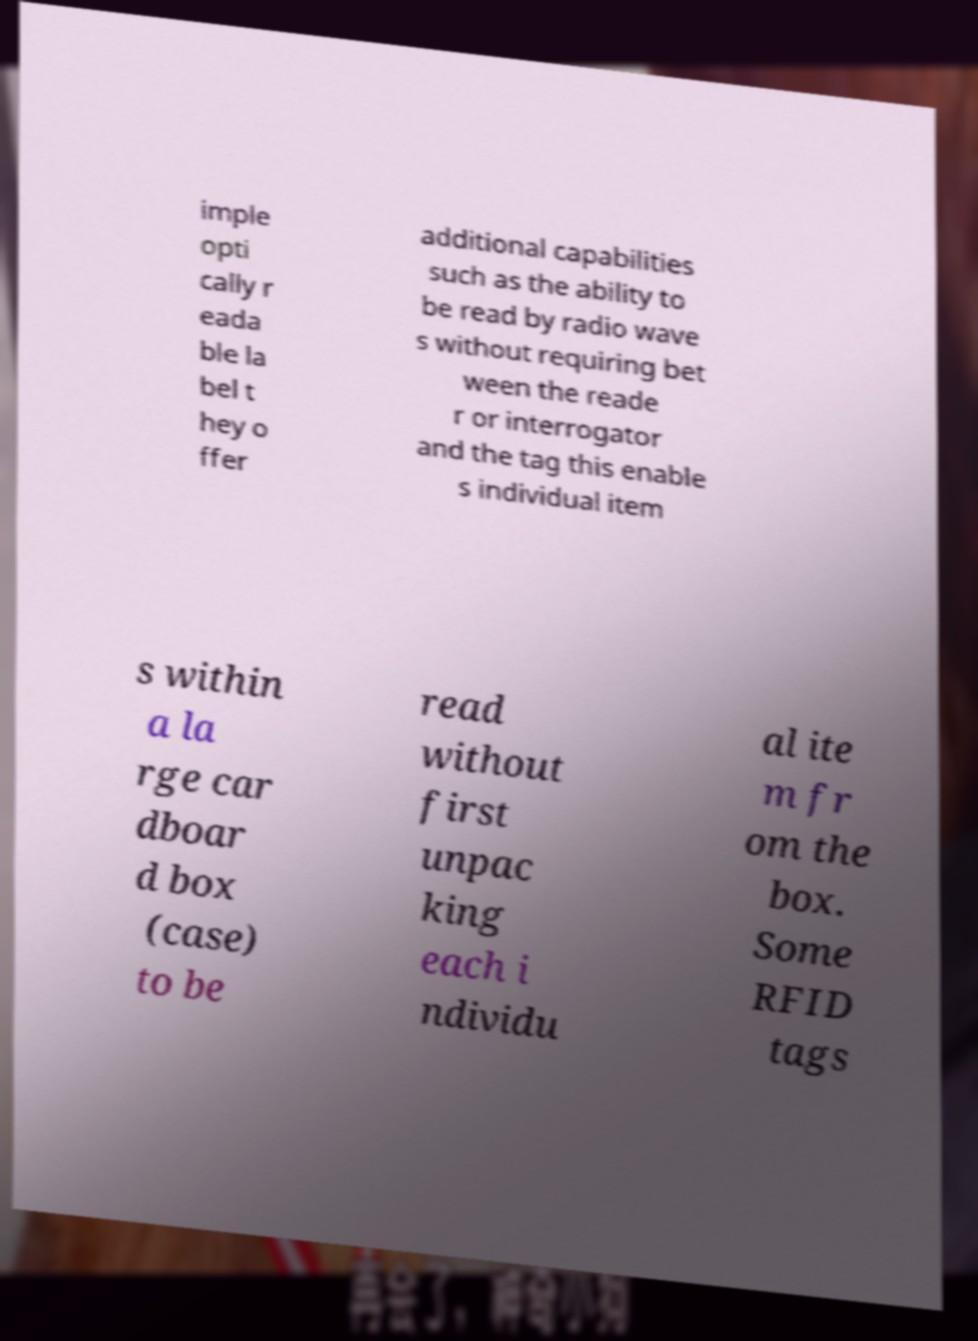There's text embedded in this image that I need extracted. Can you transcribe it verbatim? imple opti cally r eada ble la bel t hey o ffer additional capabilities such as the ability to be read by radio wave s without requiring bet ween the reade r or interrogator and the tag this enable s individual item s within a la rge car dboar d box (case) to be read without first unpac king each i ndividu al ite m fr om the box. Some RFID tags 